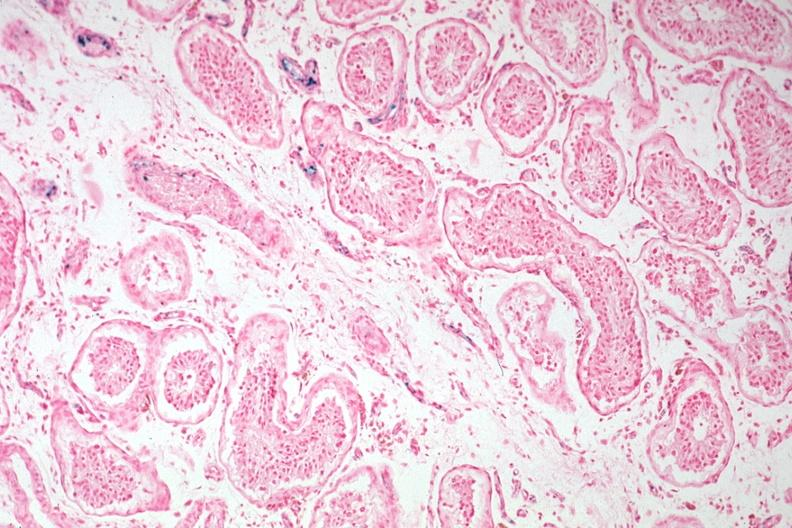what does this image show?
Answer the question using a single word or phrase. Iron stain tubular atrophy and interstitial iron deposits 